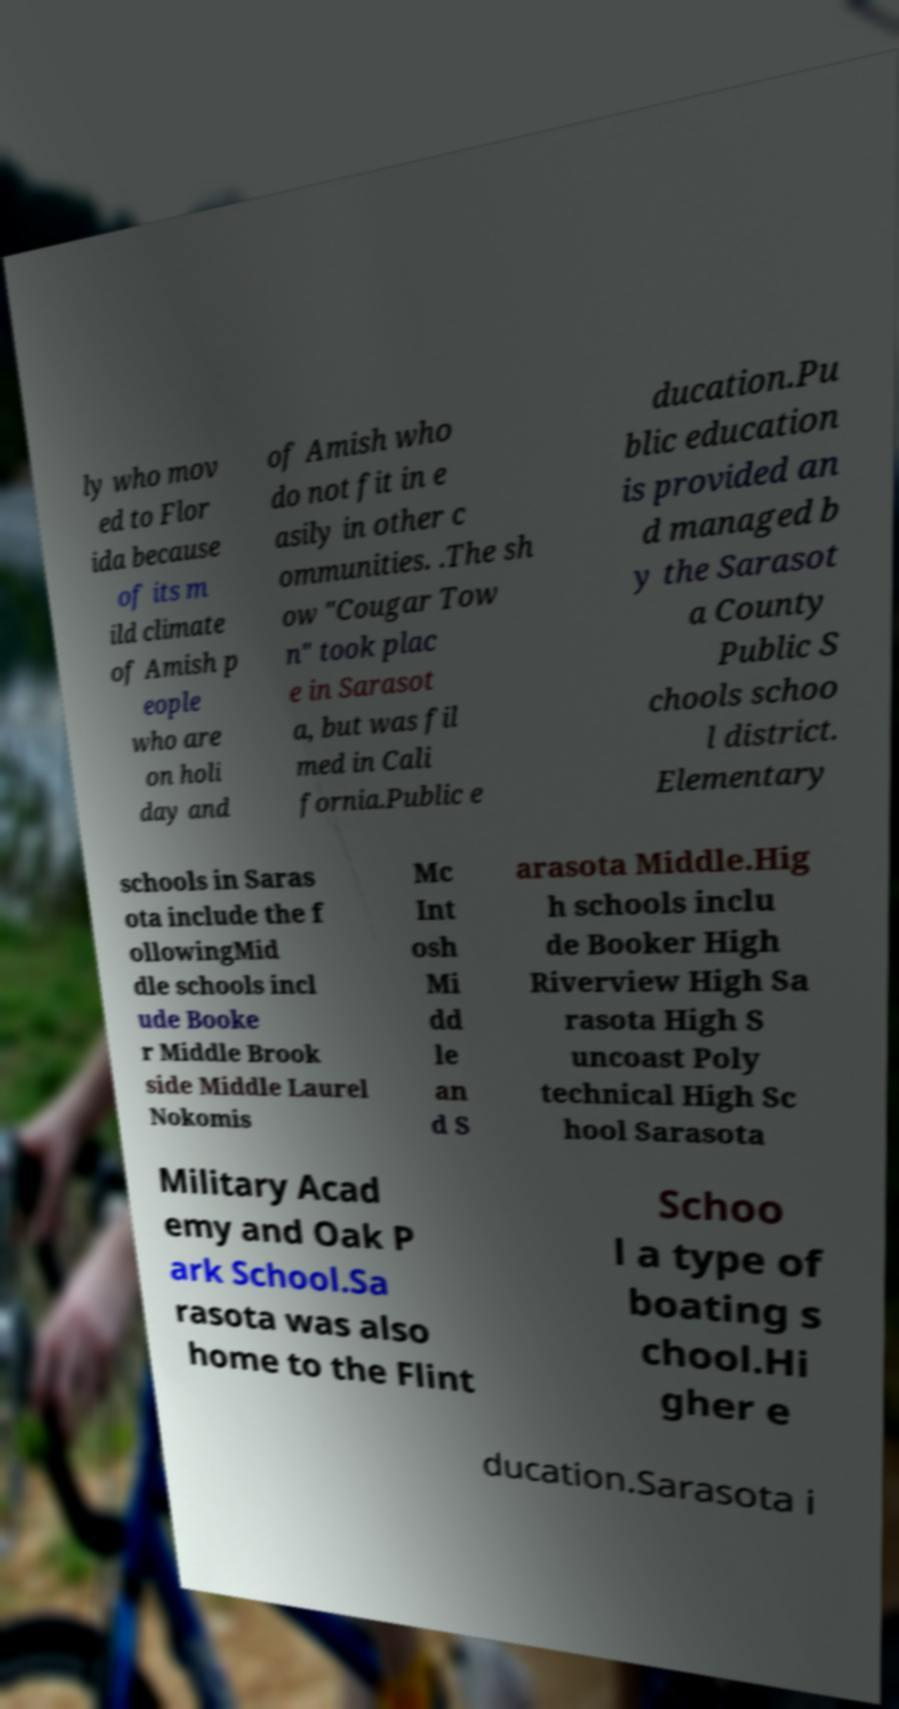Can you read and provide the text displayed in the image?This photo seems to have some interesting text. Can you extract and type it out for me? ly who mov ed to Flor ida because of its m ild climate of Amish p eople who are on holi day and of Amish who do not fit in e asily in other c ommunities. .The sh ow "Cougar Tow n" took plac e in Sarasot a, but was fil med in Cali fornia.Public e ducation.Pu blic education is provided an d managed b y the Sarasot a County Public S chools schoo l district. Elementary schools in Saras ota include the f ollowingMid dle schools incl ude Booke r Middle Brook side Middle Laurel Nokomis Mc Int osh Mi dd le an d S arasota Middle.Hig h schools inclu de Booker High Riverview High Sa rasota High S uncoast Poly technical High Sc hool Sarasota Military Acad emy and Oak P ark School.Sa rasota was also home to the Flint Schoo l a type of boating s chool.Hi gher e ducation.Sarasota i 